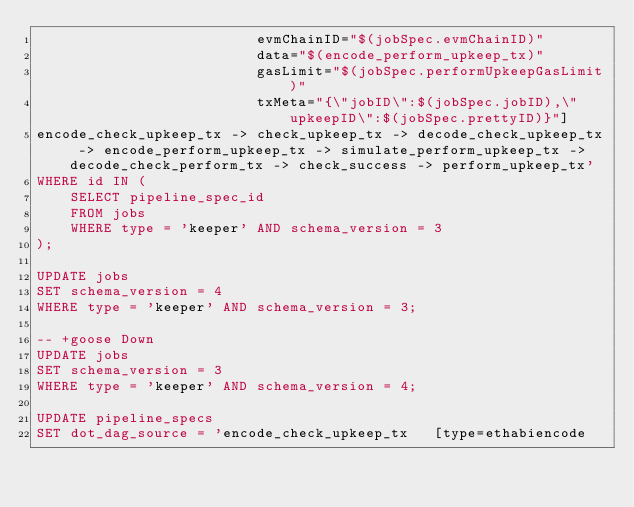Convert code to text. <code><loc_0><loc_0><loc_500><loc_500><_SQL_>                          evmChainID="$(jobSpec.evmChainID)"
                          data="$(encode_perform_upkeep_tx)"
                          gasLimit="$(jobSpec.performUpkeepGasLimit)"
                          txMeta="{\"jobID\":$(jobSpec.jobID),\"upkeepID\":$(jobSpec.prettyID)}"]
encode_check_upkeep_tx -> check_upkeep_tx -> decode_check_upkeep_tx -> encode_perform_upkeep_tx -> simulate_perform_upkeep_tx -> decode_check_perform_tx -> check_success -> perform_upkeep_tx'
WHERE id IN (
    SELECT pipeline_spec_id
    FROM jobs
    WHERE type = 'keeper' AND schema_version = 3
);

UPDATE jobs
SET schema_version = 4
WHERE type = 'keeper' AND schema_version = 3;

-- +goose Down
UPDATE jobs
SET schema_version = 3
WHERE type = 'keeper' AND schema_version = 4;

UPDATE pipeline_specs
SET dot_dag_source = 'encode_check_upkeep_tx   [type=ethabiencode</code> 